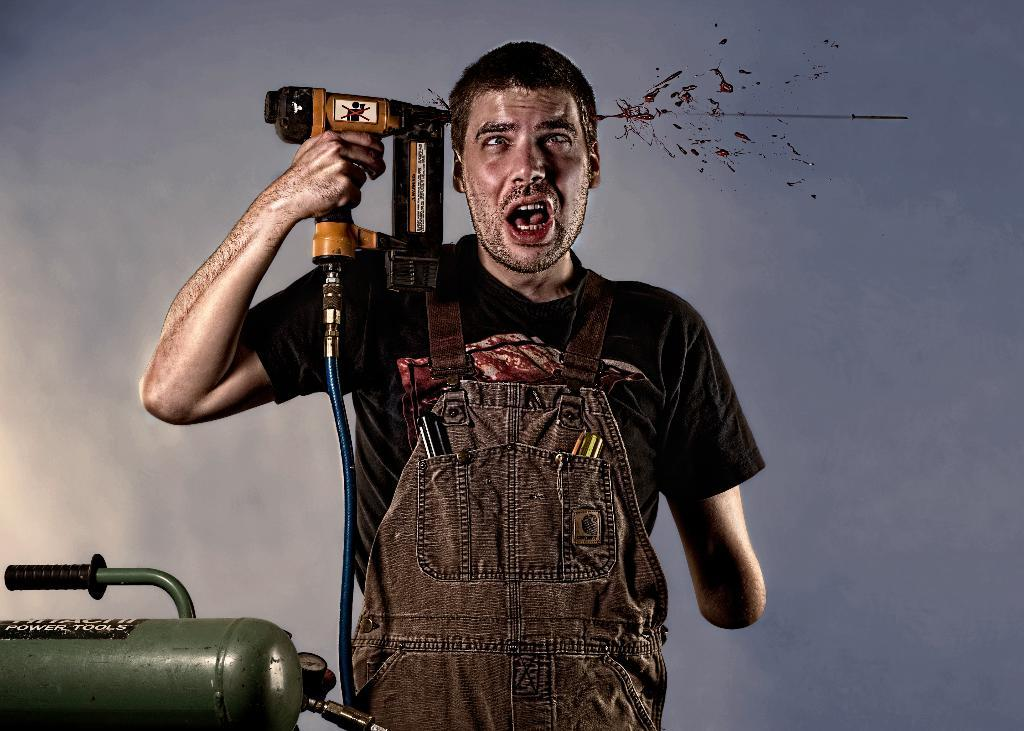What is the main subject of the image? The main subject of the image is a man. What is the man doing in the image? The man is standing in the image. What object is the man holding in his hand? The man is holding a drilling machine in his hand. Can you describe the object on the left side of the image? There is a green color object on the left side of the image. Is there a volcano erupting in the background of the image? No, there is no volcano present in the image. What type of zipper can be seen on the man's clothing in the image? There is no zipper visible on the man's clothing in the image. 